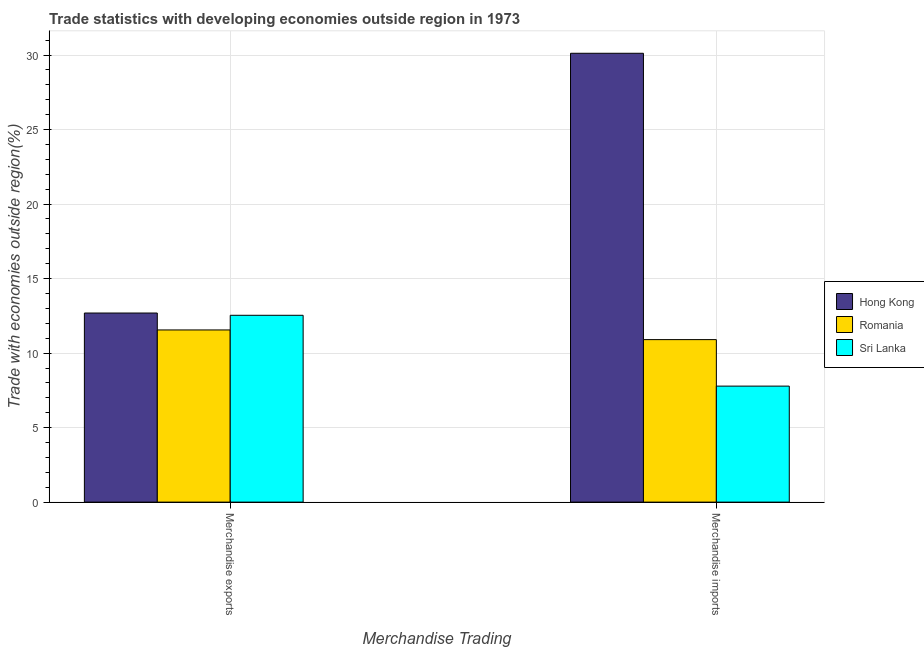Are the number of bars per tick equal to the number of legend labels?
Ensure brevity in your answer.  Yes. How many bars are there on the 1st tick from the left?
Provide a succinct answer. 3. How many bars are there on the 1st tick from the right?
Your answer should be very brief. 3. What is the label of the 1st group of bars from the left?
Your answer should be very brief. Merchandise exports. What is the merchandise exports in Hong Kong?
Provide a succinct answer. 12.69. Across all countries, what is the maximum merchandise imports?
Make the answer very short. 30.12. Across all countries, what is the minimum merchandise imports?
Your answer should be very brief. 7.78. In which country was the merchandise imports maximum?
Ensure brevity in your answer.  Hong Kong. In which country was the merchandise imports minimum?
Ensure brevity in your answer.  Sri Lanka. What is the total merchandise imports in the graph?
Offer a terse response. 48.81. What is the difference between the merchandise imports in Hong Kong and that in Romania?
Keep it short and to the point. 19.22. What is the difference between the merchandise exports in Hong Kong and the merchandise imports in Sri Lanka?
Provide a short and direct response. 4.91. What is the average merchandise imports per country?
Your answer should be very brief. 16.27. What is the difference between the merchandise exports and merchandise imports in Hong Kong?
Offer a terse response. -17.43. In how many countries, is the merchandise imports greater than 17 %?
Give a very brief answer. 1. What is the ratio of the merchandise exports in Romania to that in Hong Kong?
Give a very brief answer. 0.91. In how many countries, is the merchandise exports greater than the average merchandise exports taken over all countries?
Offer a terse response. 2. What does the 2nd bar from the left in Merchandise imports represents?
Provide a short and direct response. Romania. What does the 2nd bar from the right in Merchandise exports represents?
Your answer should be very brief. Romania. How many countries are there in the graph?
Offer a very short reply. 3. Are the values on the major ticks of Y-axis written in scientific E-notation?
Give a very brief answer. No. Does the graph contain any zero values?
Offer a very short reply. No. Does the graph contain grids?
Your response must be concise. Yes. Where does the legend appear in the graph?
Your response must be concise. Center right. How many legend labels are there?
Your answer should be very brief. 3. How are the legend labels stacked?
Offer a terse response. Vertical. What is the title of the graph?
Make the answer very short. Trade statistics with developing economies outside region in 1973. What is the label or title of the X-axis?
Provide a succinct answer. Merchandise Trading. What is the label or title of the Y-axis?
Ensure brevity in your answer.  Trade with economies outside region(%). What is the Trade with economies outside region(%) in Hong Kong in Merchandise exports?
Your response must be concise. 12.69. What is the Trade with economies outside region(%) of Romania in Merchandise exports?
Make the answer very short. 11.55. What is the Trade with economies outside region(%) in Sri Lanka in Merchandise exports?
Provide a succinct answer. 12.54. What is the Trade with economies outside region(%) in Hong Kong in Merchandise imports?
Your response must be concise. 30.12. What is the Trade with economies outside region(%) in Romania in Merchandise imports?
Ensure brevity in your answer.  10.9. What is the Trade with economies outside region(%) in Sri Lanka in Merchandise imports?
Your answer should be compact. 7.78. Across all Merchandise Trading, what is the maximum Trade with economies outside region(%) of Hong Kong?
Offer a very short reply. 30.12. Across all Merchandise Trading, what is the maximum Trade with economies outside region(%) in Romania?
Keep it short and to the point. 11.55. Across all Merchandise Trading, what is the maximum Trade with economies outside region(%) of Sri Lanka?
Ensure brevity in your answer.  12.54. Across all Merchandise Trading, what is the minimum Trade with economies outside region(%) in Hong Kong?
Keep it short and to the point. 12.69. Across all Merchandise Trading, what is the minimum Trade with economies outside region(%) of Romania?
Offer a very short reply. 10.9. Across all Merchandise Trading, what is the minimum Trade with economies outside region(%) of Sri Lanka?
Offer a very short reply. 7.78. What is the total Trade with economies outside region(%) in Hong Kong in the graph?
Make the answer very short. 42.81. What is the total Trade with economies outside region(%) of Romania in the graph?
Offer a terse response. 22.46. What is the total Trade with economies outside region(%) in Sri Lanka in the graph?
Keep it short and to the point. 20.32. What is the difference between the Trade with economies outside region(%) of Hong Kong in Merchandise exports and that in Merchandise imports?
Your response must be concise. -17.43. What is the difference between the Trade with economies outside region(%) in Romania in Merchandise exports and that in Merchandise imports?
Ensure brevity in your answer.  0.65. What is the difference between the Trade with economies outside region(%) of Sri Lanka in Merchandise exports and that in Merchandise imports?
Offer a very short reply. 4.75. What is the difference between the Trade with economies outside region(%) of Hong Kong in Merchandise exports and the Trade with economies outside region(%) of Romania in Merchandise imports?
Your response must be concise. 1.78. What is the difference between the Trade with economies outside region(%) in Hong Kong in Merchandise exports and the Trade with economies outside region(%) in Sri Lanka in Merchandise imports?
Keep it short and to the point. 4.91. What is the difference between the Trade with economies outside region(%) of Romania in Merchandise exports and the Trade with economies outside region(%) of Sri Lanka in Merchandise imports?
Ensure brevity in your answer.  3.77. What is the average Trade with economies outside region(%) in Hong Kong per Merchandise Trading?
Your response must be concise. 21.4. What is the average Trade with economies outside region(%) in Romania per Merchandise Trading?
Offer a very short reply. 11.23. What is the average Trade with economies outside region(%) of Sri Lanka per Merchandise Trading?
Provide a short and direct response. 10.16. What is the difference between the Trade with economies outside region(%) of Hong Kong and Trade with economies outside region(%) of Romania in Merchandise exports?
Give a very brief answer. 1.14. What is the difference between the Trade with economies outside region(%) of Hong Kong and Trade with economies outside region(%) of Sri Lanka in Merchandise exports?
Your answer should be compact. 0.15. What is the difference between the Trade with economies outside region(%) in Romania and Trade with economies outside region(%) in Sri Lanka in Merchandise exports?
Offer a terse response. -0.98. What is the difference between the Trade with economies outside region(%) of Hong Kong and Trade with economies outside region(%) of Romania in Merchandise imports?
Offer a terse response. 19.22. What is the difference between the Trade with economies outside region(%) of Hong Kong and Trade with economies outside region(%) of Sri Lanka in Merchandise imports?
Give a very brief answer. 22.34. What is the difference between the Trade with economies outside region(%) in Romania and Trade with economies outside region(%) in Sri Lanka in Merchandise imports?
Provide a short and direct response. 3.12. What is the ratio of the Trade with economies outside region(%) in Hong Kong in Merchandise exports to that in Merchandise imports?
Keep it short and to the point. 0.42. What is the ratio of the Trade with economies outside region(%) of Romania in Merchandise exports to that in Merchandise imports?
Your response must be concise. 1.06. What is the ratio of the Trade with economies outside region(%) in Sri Lanka in Merchandise exports to that in Merchandise imports?
Make the answer very short. 1.61. What is the difference between the highest and the second highest Trade with economies outside region(%) in Hong Kong?
Provide a short and direct response. 17.43. What is the difference between the highest and the second highest Trade with economies outside region(%) in Romania?
Provide a succinct answer. 0.65. What is the difference between the highest and the second highest Trade with economies outside region(%) of Sri Lanka?
Provide a succinct answer. 4.75. What is the difference between the highest and the lowest Trade with economies outside region(%) of Hong Kong?
Offer a terse response. 17.43. What is the difference between the highest and the lowest Trade with economies outside region(%) of Romania?
Your answer should be compact. 0.65. What is the difference between the highest and the lowest Trade with economies outside region(%) in Sri Lanka?
Provide a short and direct response. 4.75. 